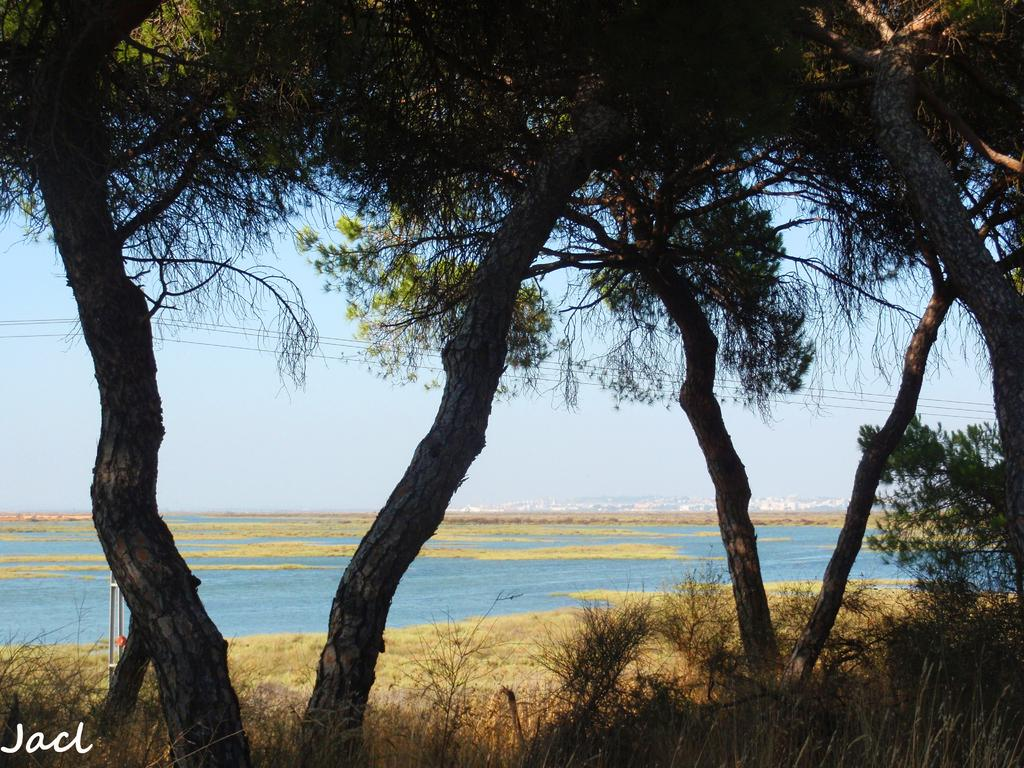What type of terrain is at the bottom side of the image? There is grassland at the bottom side of the image. What type of vegetation is at the top side of the image? There are trees at the top side of the image. What can be seen in the background of the image? There is water visible in the background area of the image. What type of brass object can be seen in the image? There is no brass object present in the image. Is the grassland in the image arranged in a square shape? The grassland in the image is not arranged in a square shape; it is a natural terrain feature. 